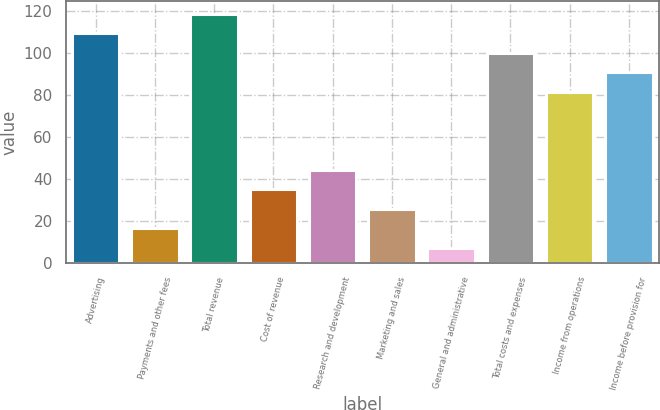<chart> <loc_0><loc_0><loc_500><loc_500><bar_chart><fcel>Advertising<fcel>Payments and other fees<fcel>Total revenue<fcel>Cost of revenue<fcel>Research and development<fcel>Marketing and sales<fcel>General and administrative<fcel>Total costs and expenses<fcel>Income from operations<fcel>Income before provision for<nl><fcel>109.3<fcel>16.3<fcel>118.6<fcel>34.9<fcel>44.2<fcel>25.6<fcel>7<fcel>100<fcel>81.4<fcel>90.7<nl></chart> 